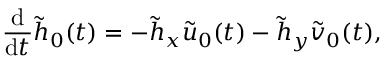<formula> <loc_0><loc_0><loc_500><loc_500>\frac { d } { d t } \tilde { h } _ { 0 } ( t ) = - \tilde { h } _ { x } \tilde { u } _ { 0 } ( t ) - \tilde { h } _ { y } \tilde { v } _ { 0 } ( t ) ,</formula> 